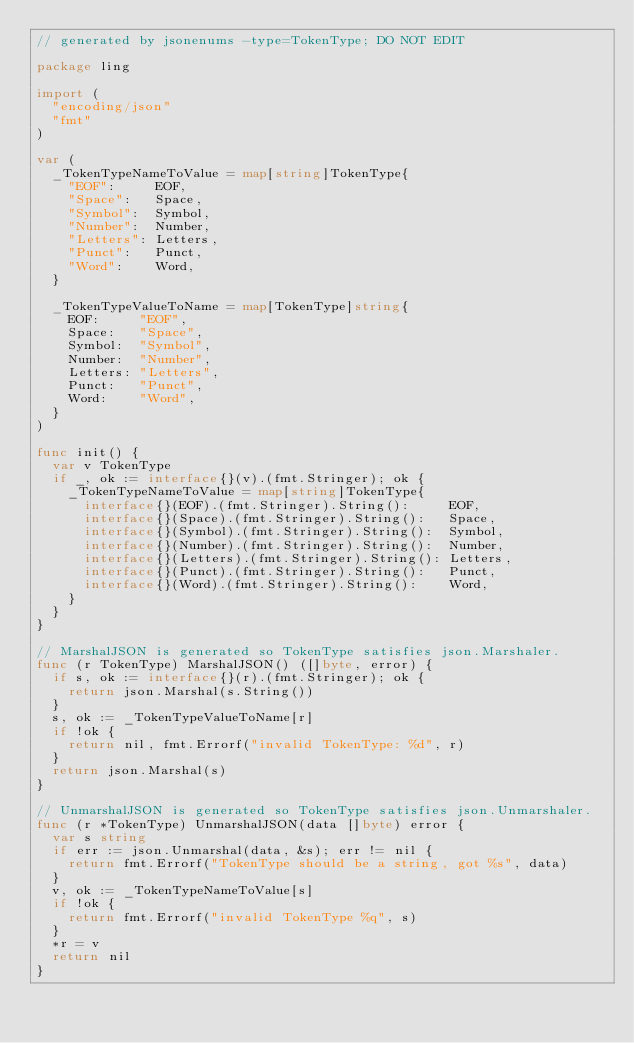Convert code to text. <code><loc_0><loc_0><loc_500><loc_500><_Go_>// generated by jsonenums -type=TokenType; DO NOT EDIT

package ling

import (
	"encoding/json"
	"fmt"
)

var (
	_TokenTypeNameToValue = map[string]TokenType{
		"EOF":     EOF,
		"Space":   Space,
		"Symbol":  Symbol,
		"Number":  Number,
		"Letters": Letters,
		"Punct":   Punct,
		"Word":    Word,
	}

	_TokenTypeValueToName = map[TokenType]string{
		EOF:     "EOF",
		Space:   "Space",
		Symbol:  "Symbol",
		Number:  "Number",
		Letters: "Letters",
		Punct:   "Punct",
		Word:    "Word",
	}
)

func init() {
	var v TokenType
	if _, ok := interface{}(v).(fmt.Stringer); ok {
		_TokenTypeNameToValue = map[string]TokenType{
			interface{}(EOF).(fmt.Stringer).String():     EOF,
			interface{}(Space).(fmt.Stringer).String():   Space,
			interface{}(Symbol).(fmt.Stringer).String():  Symbol,
			interface{}(Number).(fmt.Stringer).String():  Number,
			interface{}(Letters).(fmt.Stringer).String(): Letters,
			interface{}(Punct).(fmt.Stringer).String():   Punct,
			interface{}(Word).(fmt.Stringer).String():    Word,
		}
	}
}

// MarshalJSON is generated so TokenType satisfies json.Marshaler.
func (r TokenType) MarshalJSON() ([]byte, error) {
	if s, ok := interface{}(r).(fmt.Stringer); ok {
		return json.Marshal(s.String())
	}
	s, ok := _TokenTypeValueToName[r]
	if !ok {
		return nil, fmt.Errorf("invalid TokenType: %d", r)
	}
	return json.Marshal(s)
}

// UnmarshalJSON is generated so TokenType satisfies json.Unmarshaler.
func (r *TokenType) UnmarshalJSON(data []byte) error {
	var s string
	if err := json.Unmarshal(data, &s); err != nil {
		return fmt.Errorf("TokenType should be a string, got %s", data)
	}
	v, ok := _TokenTypeNameToValue[s]
	if !ok {
		return fmt.Errorf("invalid TokenType %q", s)
	}
	*r = v
	return nil
}
</code> 